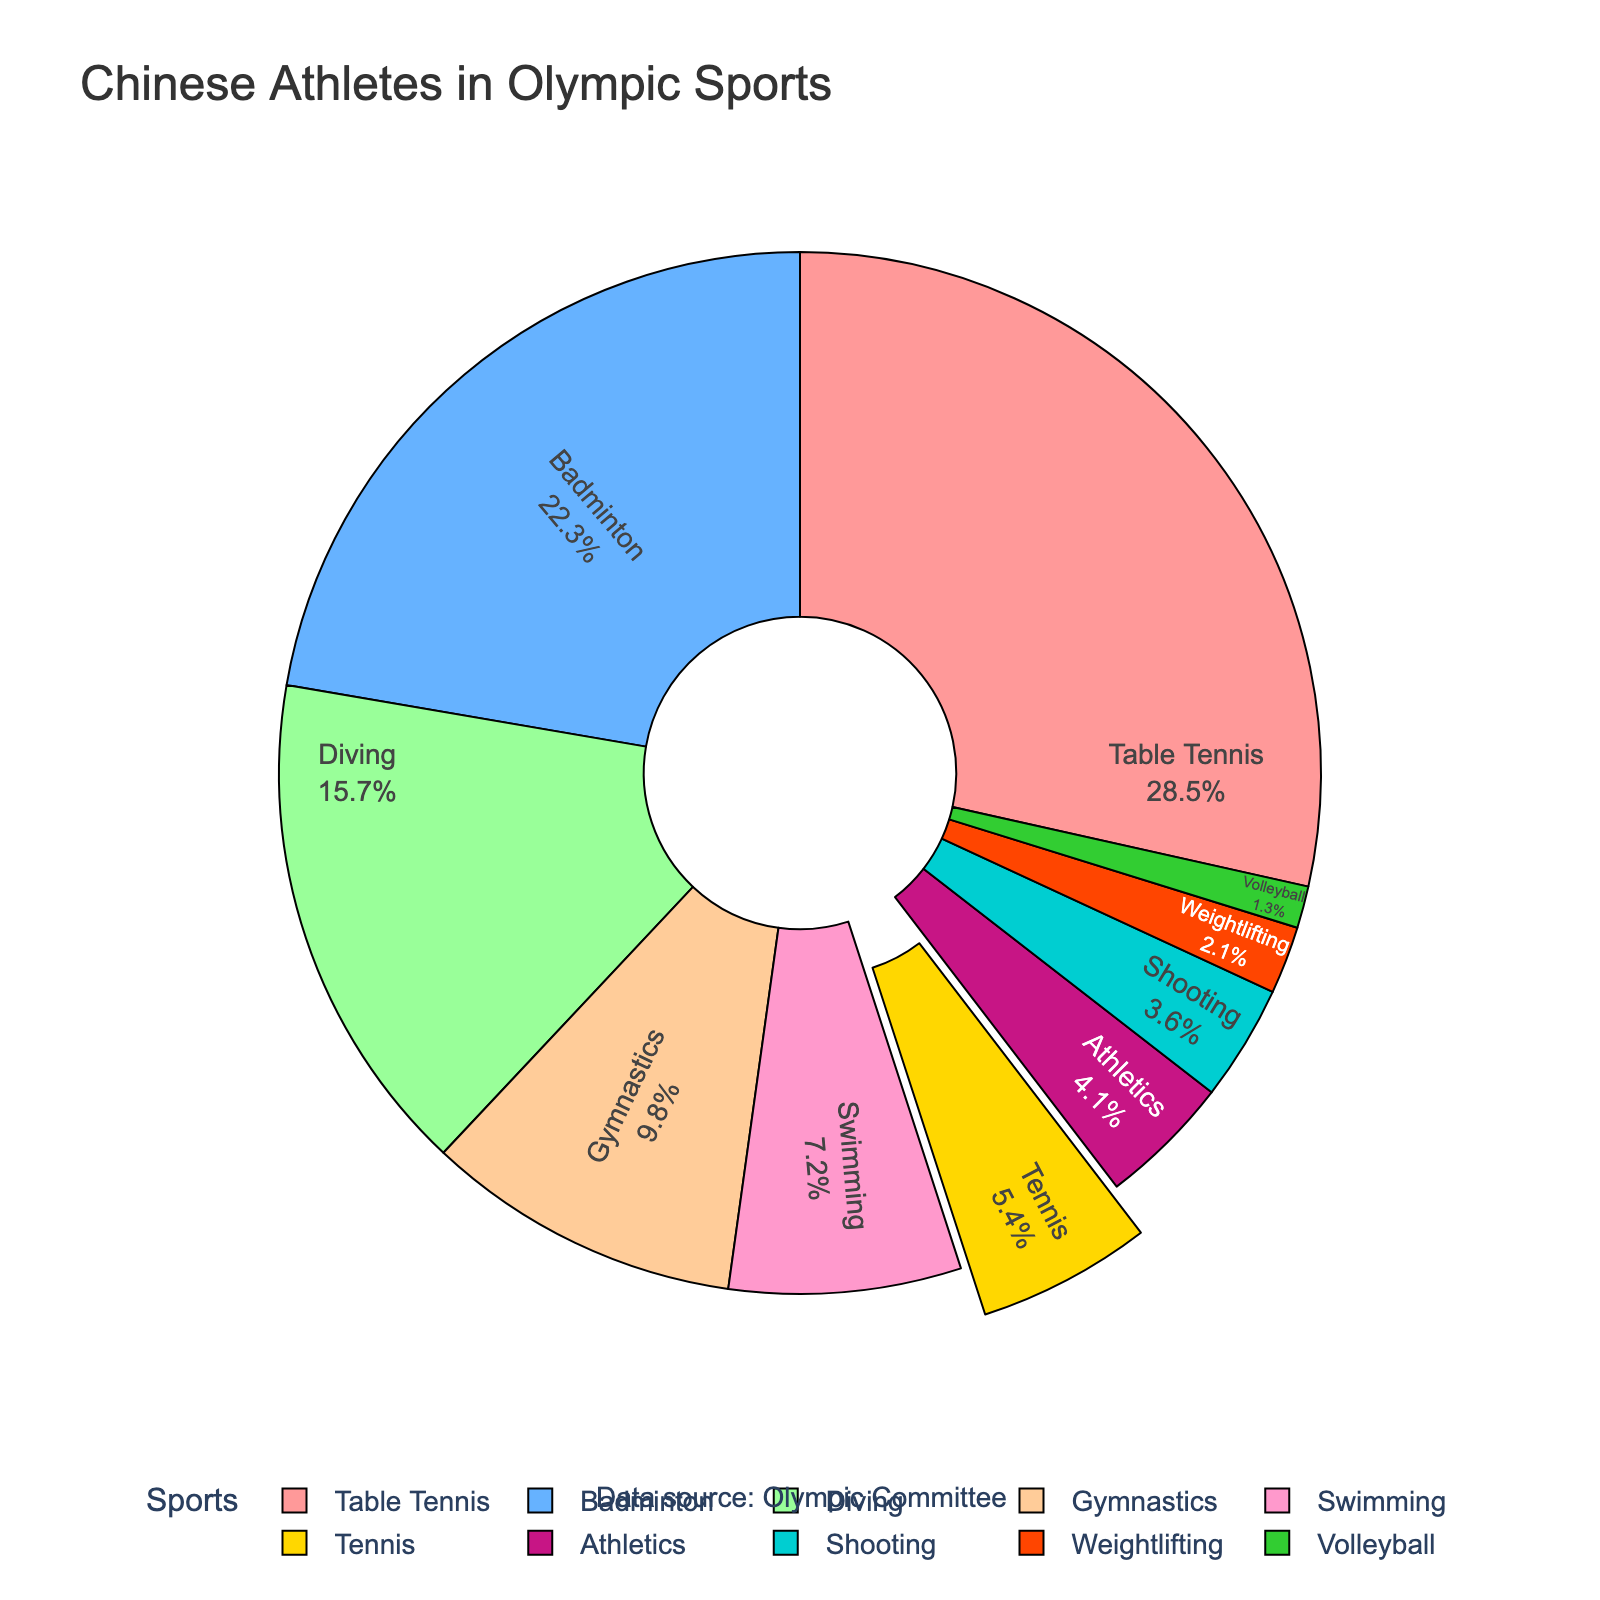What percentage of Chinese athletes compete in Volleyball? The pie chart shows the percentage data for different sports. Locate the segment labeled "Volleyball" and read its percentage value.
Answer: 1.3% Which sport has the highest percentage of Chinese athletes? By scanning the pie chart, the largest segment corresponds to the sport with the highest percentage. In this case, it’s Table Tennis.
Answer: Table Tennis How does the percentage of Chinese athletes in Tennis compare to that in Diving? Find the percentage values for Tennis and Diving. Note that Tennis is 5.4% and Diving is 15.7%. Compare these values.
Answer: Diving has a higher percentage than Tennis What is the combined percentage of Chinese athletes in Swimming and Gymnastics? Find the respective percentages for Swimming (7.2%) and Gymnastics (9.8%). Add these values together: 7.2% + 9.8% = 17%.
Answer: 17% Which sports have a greater percentage of Chinese athletes than Tennis? Identify the percentage value of Tennis (5.4%) and then find all the sports with percentages greater than this value: Table Tennis (28.5%), Badminton (22.3%), Diving (15.7%), Gymnastics (9.8%), Swimming (7.2%).
Answer: Table Tennis, Badminton, Diving, Gymnastics, Swimming What is the smallest segment in the pie chart and what sport does it represent? Observe the pie chart and find the smallest segment. It represents Volleyball at 1.3%.
Answer: Volleyball How much larger is the percentage for Table Tennis compared to Weightlifting? Find the percentages for Table Tennis (28.5%) and Weightlifting (2.1%). Calculate the difference: 28.5% - 2.1% = 26.4%.
Answer: 26.4% What is the total percentage of Chinese athletes in sports other than Tennis? Find the percentage for Tennis (5.4%) and subtract it from 100% to get the combined percentage for all other sports: 100% - 5.4% = 94.6%.
Answer: 94.6% Is there a sport where the percentage of Chinese athletes is exactly half of that in Badminton? The percentage for Badminton is 22.3%. Half of this value is 11.15%. Scan the pie chart to see if there is any sport with this percentage. There is none.
Answer: No Which color represents Tennis in the pie chart? The Tennis segment is pulled out slightly. Locate this segment and identify its color, which is gold (yellow).
Answer: Gold (yellow) 